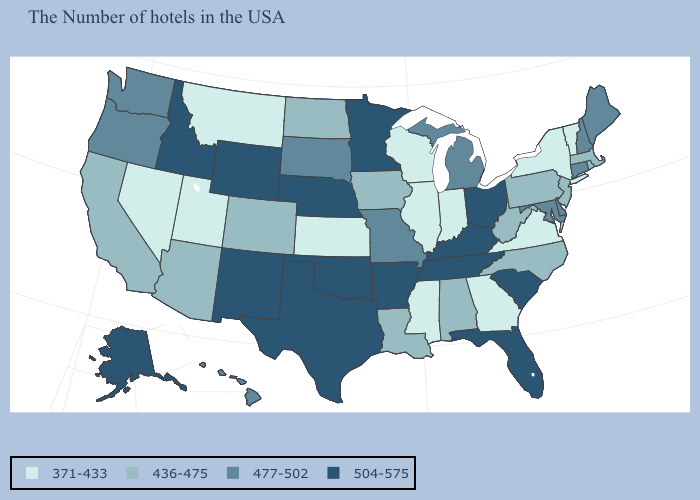Does Nebraska have the highest value in the MidWest?
Be succinct. Yes. Among the states that border Washington , does Idaho have the lowest value?
Quick response, please. No. What is the value of Delaware?
Concise answer only. 477-502. Among the states that border Mississippi , does Arkansas have the lowest value?
Give a very brief answer. No. What is the highest value in states that border Nebraska?
Short answer required. 504-575. Among the states that border Kansas , does Colorado have the highest value?
Answer briefly. No. Name the states that have a value in the range 436-475?
Keep it brief. Massachusetts, Rhode Island, New Jersey, Pennsylvania, North Carolina, West Virginia, Alabama, Louisiana, Iowa, North Dakota, Colorado, Arizona, California. What is the value of New Jersey?
Quick response, please. 436-475. How many symbols are there in the legend?
Concise answer only. 4. Does the map have missing data?
Answer briefly. No. Name the states that have a value in the range 477-502?
Short answer required. Maine, New Hampshire, Connecticut, Delaware, Maryland, Michigan, Missouri, South Dakota, Washington, Oregon, Hawaii. What is the value of New York?
Give a very brief answer. 371-433. What is the lowest value in the USA?
Keep it brief. 371-433. What is the lowest value in the South?
Keep it brief. 371-433. Name the states that have a value in the range 477-502?
Concise answer only. Maine, New Hampshire, Connecticut, Delaware, Maryland, Michigan, Missouri, South Dakota, Washington, Oregon, Hawaii. 